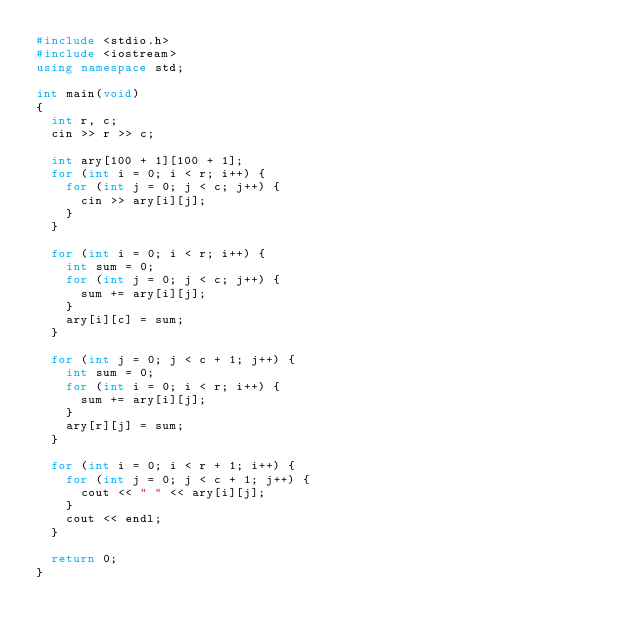Convert code to text. <code><loc_0><loc_0><loc_500><loc_500><_C++_>#include <stdio.h>
#include <iostream>
using namespace std;

int main(void)
{		
	int r, c;
	cin >> r >> c;
	
	int ary[100 + 1][100 + 1];
	for (int i = 0; i < r; i++) {
		for (int j = 0; j < c; j++) {
			cin >> ary[i][j];
		}
	}
	
	for (int i = 0; i < r; i++) {
		int sum = 0;
		for (int j = 0; j < c; j++) {
			sum += ary[i][j];
		}
		ary[i][c] = sum;
	}
	
	for (int j = 0; j < c + 1; j++) {
		int sum = 0;
		for (int i = 0; i < r; i++) {
			sum += ary[i][j];
		}
		ary[r][j] = sum;
	}
	
	for (int i = 0; i < r + 1; i++) {
		for (int j = 0; j < c + 1; j++) {
			cout << " " << ary[i][j];
		}
		cout << endl;
	}
	
	return 0;
}</code> 